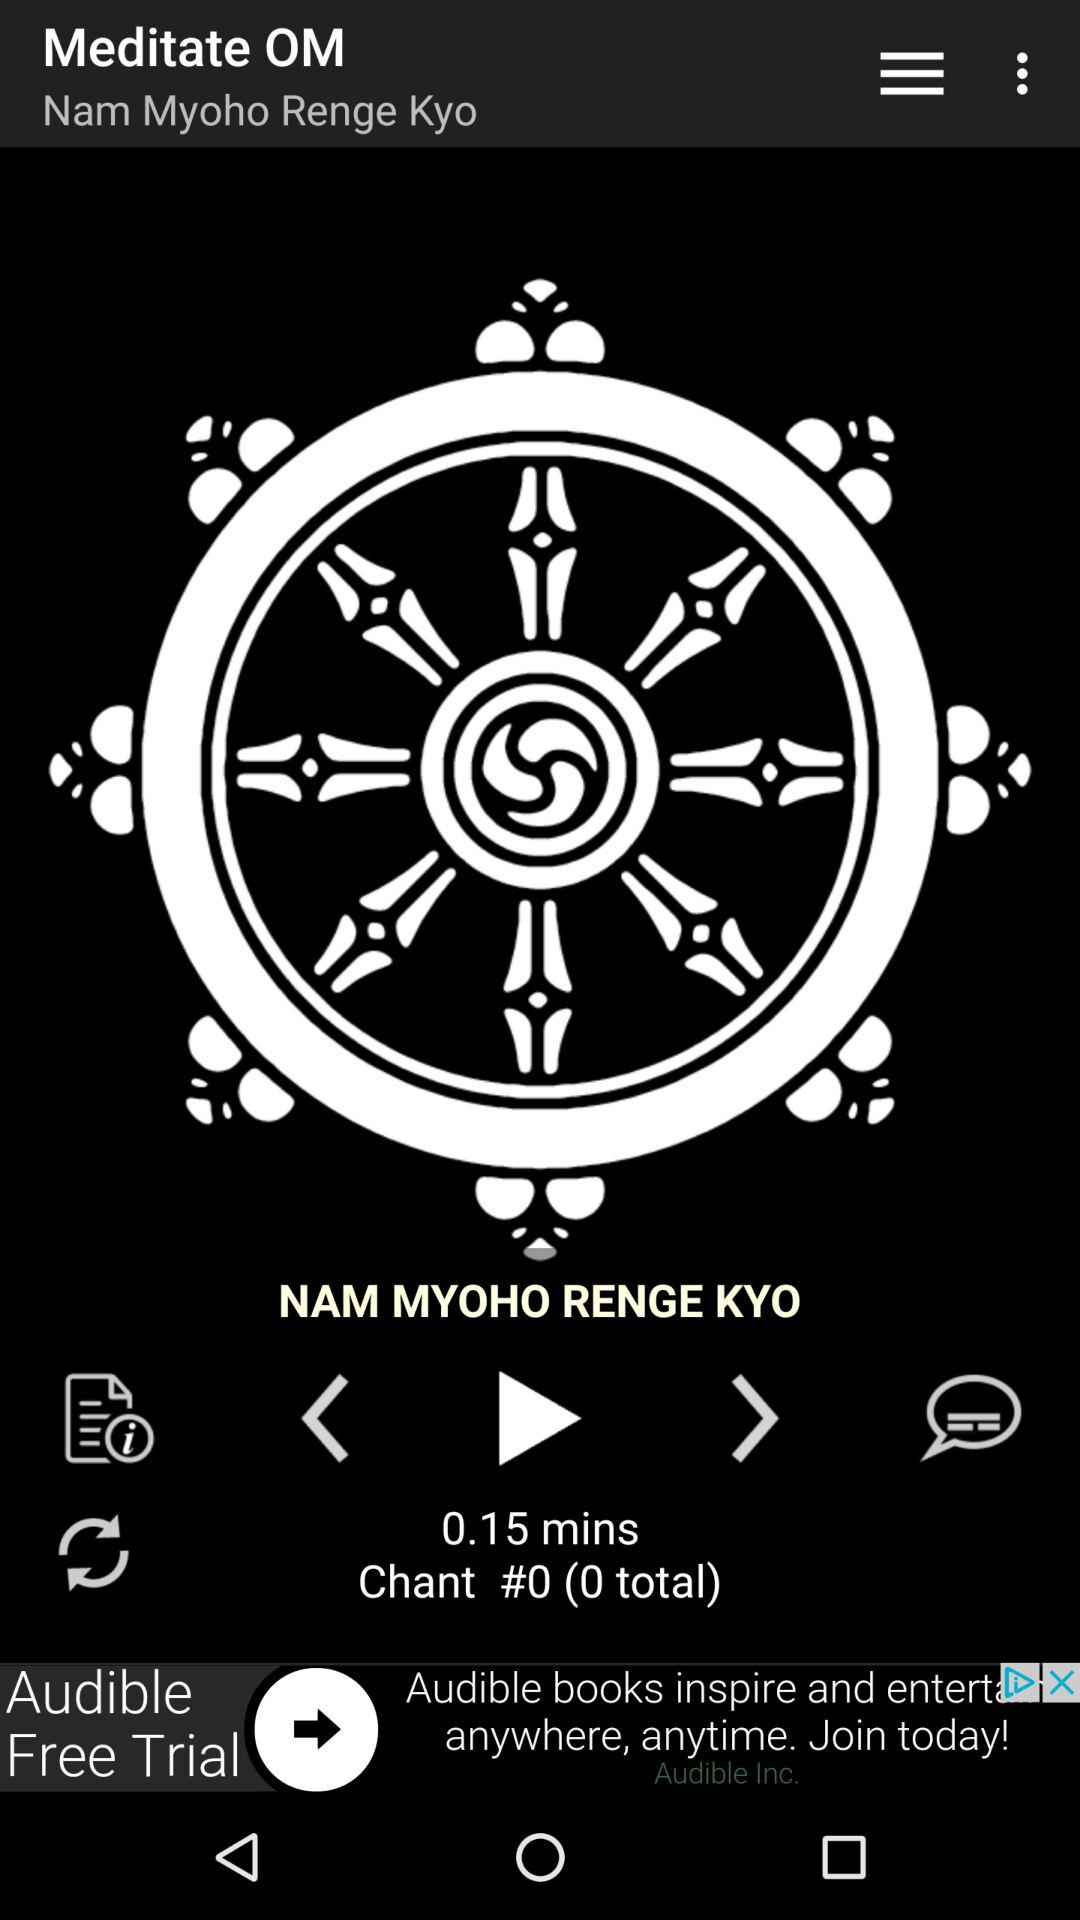How many chants have been recorded?
Answer the question using a single word or phrase. 0 